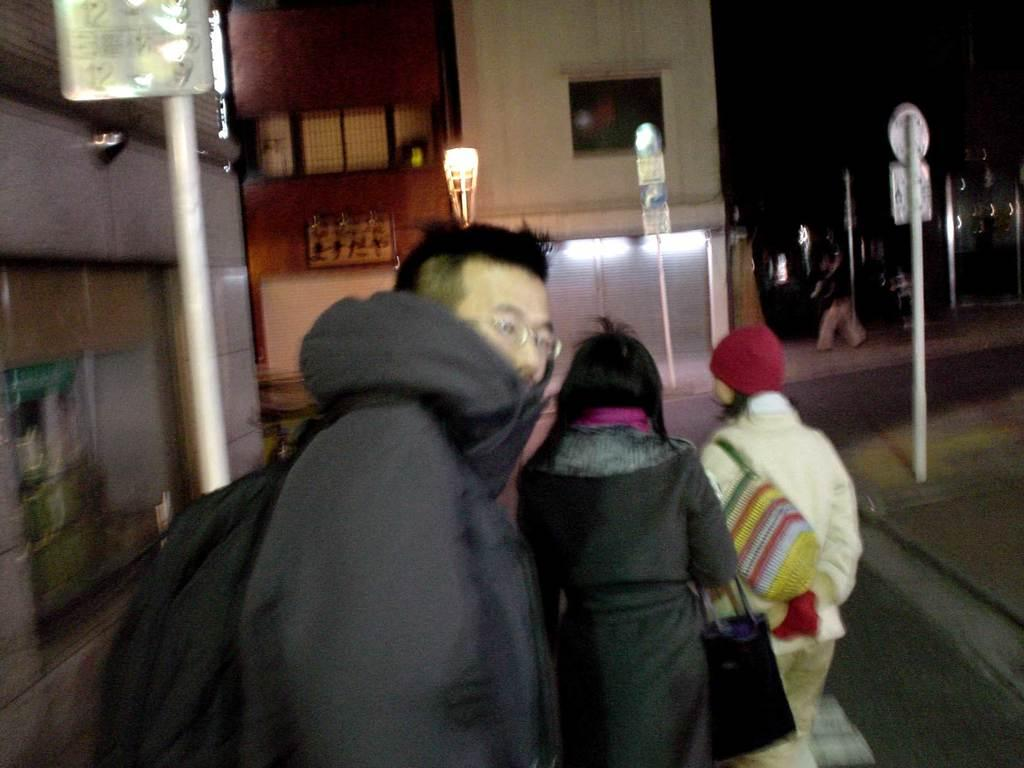What are the people in the image wearing? The people in the image are wearing bags. What can be seen in the background of the image? There are houses, walls, poles, sign boards, and light visible in the background of the image. Can you describe the person on the right side of the image? There is a person walking on the right side of the image. What type of plant is the scarecrow holding in the image? There is no plant or scarecrow present in the image. 